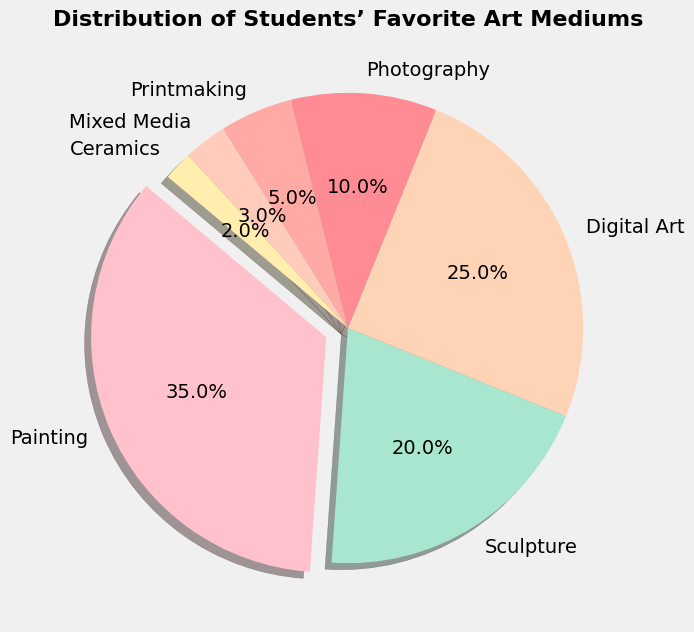What's the most preferred art medium among students? The slice representing the most preferred art medium will have the largest percentage. According to the chart, "Painting" has the largest slice at 35%.
Answer: Painting Which art medium has the second-largest percentage? To identify the second-largest percentage, look for the second-largest slice. "Digital Art" at 25% is the second-largest.
Answer: Digital Art How much greater is the percentage of students who prefer Painting compared to Sculpture? First, find the percentage for both segments: Painting (35%) and Sculpture (20%). Subtract Sculpture from Painting: 35% - 20% = 15%.
Answer: 15% Which art mediums constitute less than 10% of the students' preferences? To determine this, look for slices with percentages below 10%. These are "Photography" (10%), "Printmaking" (5%), "Mixed Media" (3%), and "Ceramics" (2%).
Answer: Printmaking, Mixed Media, Ceramics What is the combined percentage of students who prefer Printmaking and Ceramics? Add the percentages of both Printmaking (5%) and Ceramics (2%): 5% + 2% = 7%.
Answer: 7% Which color slice represents Sculpture, and what is its percentage? The slice representing Sculpture will be colored in '#A8E6CF', which translates to a soft green. This slice has a percentage of 20%.
Answer: Green, 20% How much larger is the percentage of students favoring Digital Art compared to Photography? First, find the percentages: Digital Art (25%) and Photography (10%). Subtract Photography from Digital Art: 25% - 10% = 15%.
Answer: 15% Are there more students who prefer Painting or Digital Art and by what percentage difference? Compare the percentages: Painting (35%) and Digital Art (25%). Subtract Digital Art from Painting: 35% - 25% = 10%.
Answer: Painting, 10% What's the total percentage of students that prefer Mixed Media and Ceramics combined? Add the percentages of Mixed Media (3%) and Ceramics (2%): 3% + 2% = 5%.
Answer: 5% Which art medium represents the smallest slice on the pie chart, and what is its percentage? The smallest slice on the pie chart indicates the medium with the least preference. "Ceramics" has the smallest slice with a percentage of 2%.
Answer: Ceramics, 2% 